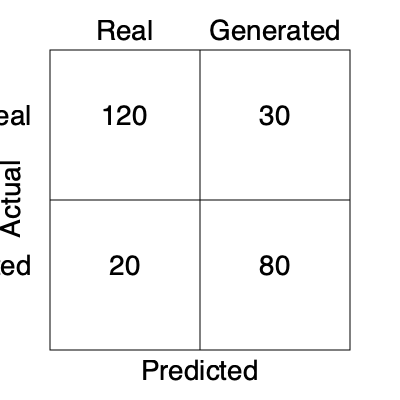Given the confusion matrix for a GAN-based image classification system, what is the precision of the model in identifying real images? To calculate the precision for real images, we need to follow these steps:

1. Understand the confusion matrix:
   - True Positives (TP): 120 (Real images correctly classified as real)
   - False Positives (FP): 20 (Generated images incorrectly classified as real)
   - False Negatives (FN): 30 (Real images incorrectly classified as generated)
   - True Negatives (TN): 80 (Generated images correctly classified as generated)

2. Recall the formula for precision:
   $$ \text{Precision} = \frac{\text{True Positives}}{\text{True Positives} + \text{False Positives}} $$

3. Substitute the values:
   $$ \text{Precision} = \frac{120}{120 + 20} = \frac{120}{140} $$

4. Perform the calculation:
   $$ \text{Precision} = \frac{120}{140} \approx 0.8571 $$

5. Convert to percentage:
   $$ \text{Precision} \approx 85.71\% $$

Therefore, the precision of the model in identifying real images is approximately 85.71%.
Answer: 85.71% 